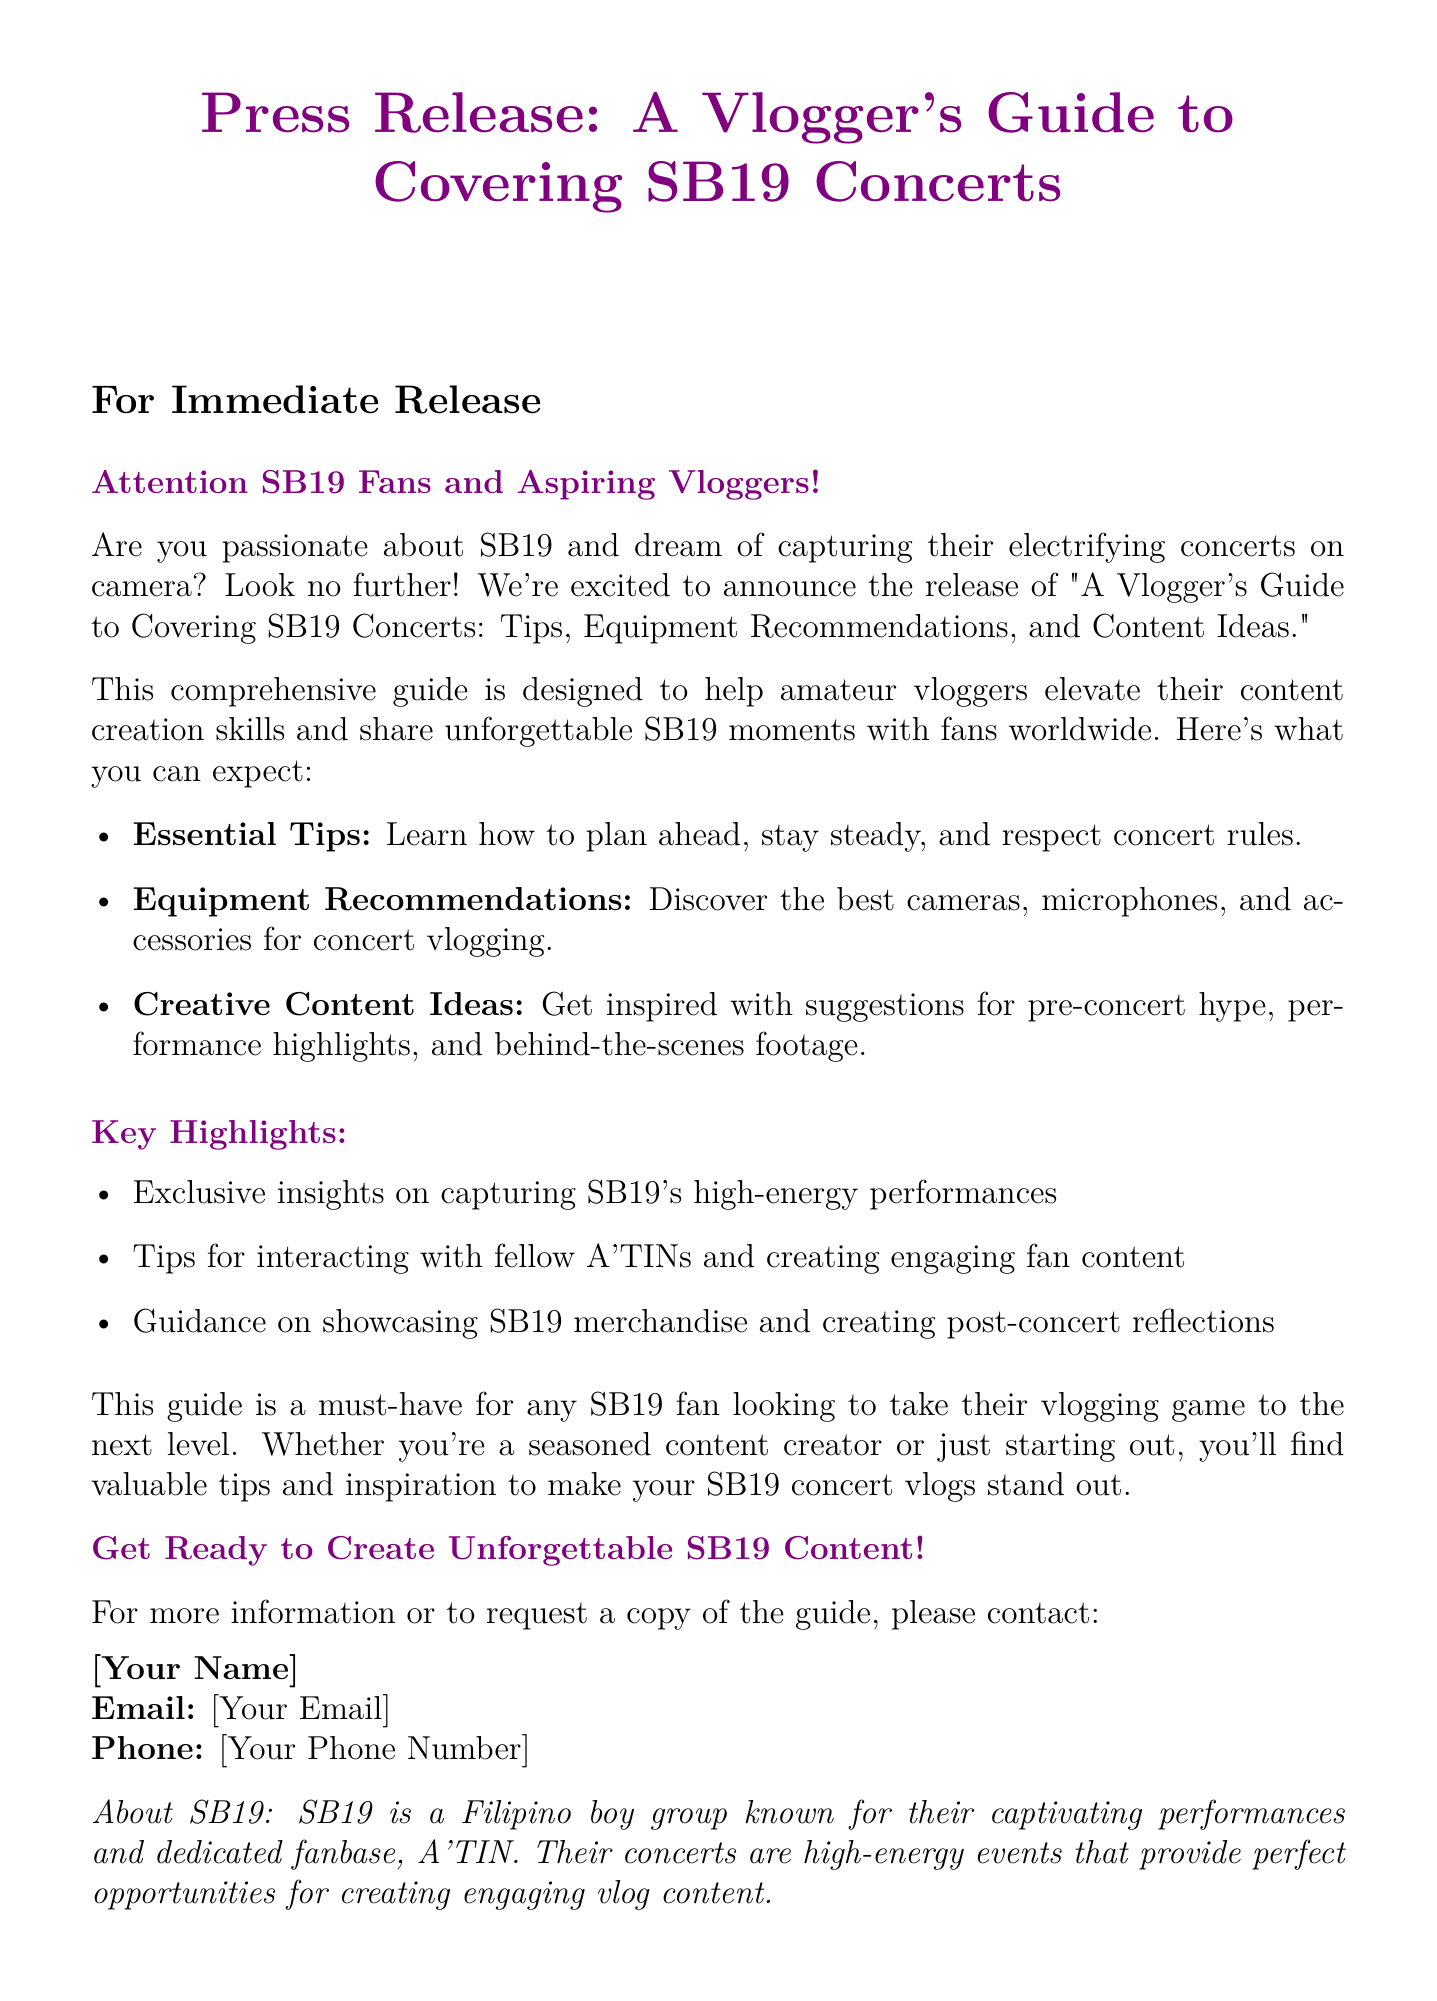What is the title of the guide? The title of the guide is explicitly stated in the document as "A Vlogger's Guide to Covering SB19 Concerts: Tips, Equipment Recommendations, and Content Ideas."
Answer: A Vlogger's Guide to Covering SB19 Concerts: Tips, Equipment Recommendations, and Content Ideas Who is the target audience for the guide? The target audience is described in the document as SB19 fans and aspiring vloggers.
Answer: SB19 fans and aspiring vloggers What type of recommendations does the guide include? The guide includes recommendations for cameras, microphones, and accessories related to concert vlogging.
Answer: Equipment Recommendations Name one type of content idea suggested in the guide. The document mentions pre-concert hype, performance highlights, and behind-the-scenes footage, which can be considered as content ideas.
Answer: Pre-concert hype Which fanbase is mentioned in the document? The fanbase mentioned in the document is the A'TIN.
Answer: A'TIN How are SB19 concerts described in the document? The concerts are described as high-energy events that provide perfect opportunities for creating engaging vlog content.
Answer: High-energy events What color is used as the title color in the document? The color used for the title in the document is explicitly stated as "sb19purple."
Answer: sb19purple What is the purpose of the press release? The purpose is to announce the release of the vlogger's guide for covering SB19 concerts.
Answer: To announce the release of the vlogger's guide Who should you contact for more information? The document suggests contacting an unspecified person, providing their email and phone number for inquiries.
Answer: [Your Name] 